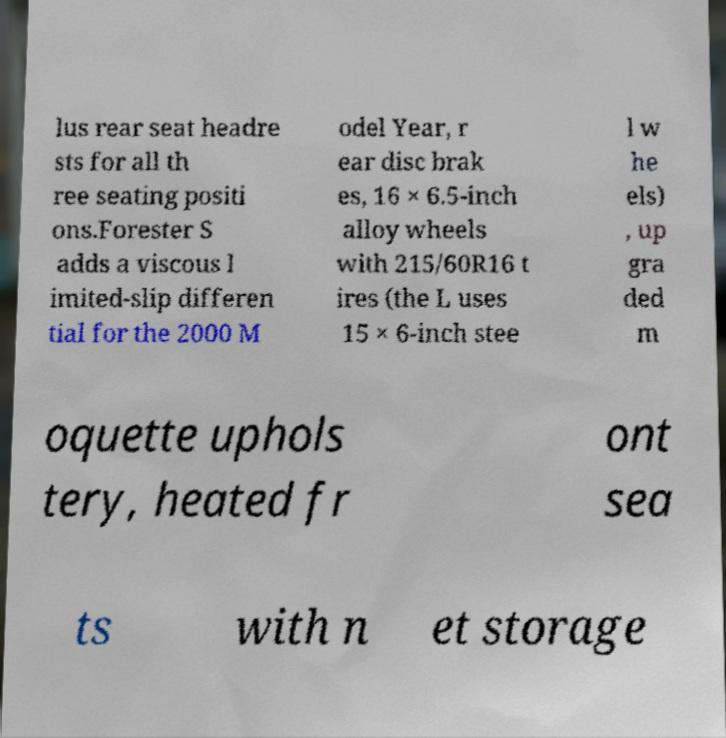Could you assist in decoding the text presented in this image and type it out clearly? lus rear seat headre sts for all th ree seating positi ons.Forester S adds a viscous l imited-slip differen tial for the 2000 M odel Year, r ear disc brak es, 16 × 6.5-inch alloy wheels with 215/60R16 t ires (the L uses 15 × 6-inch stee l w he els) , up gra ded m oquette uphols tery, heated fr ont sea ts with n et storage 